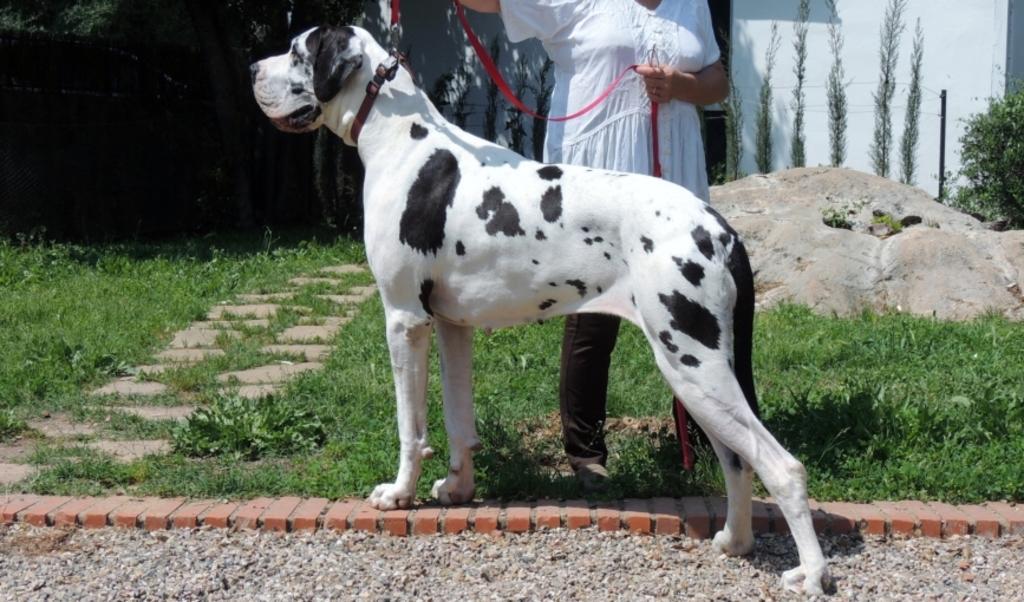Describe this image in one or two sentences. In this image we can see a dog and a person holding a dog leash, there is grass, and, few plants, trees and a wall in the background. 